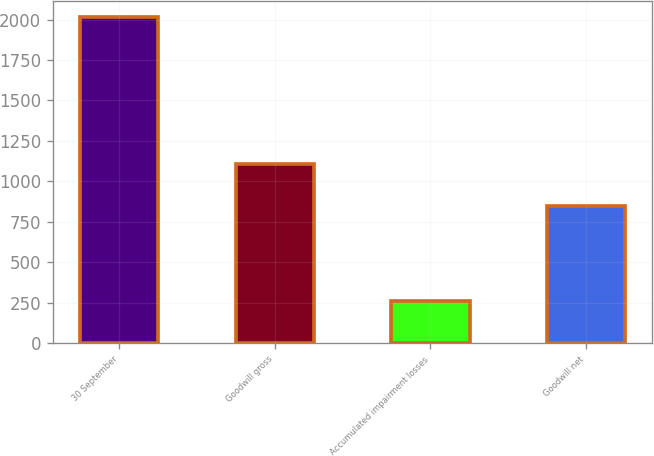Convert chart to OTSL. <chart><loc_0><loc_0><loc_500><loc_500><bar_chart><fcel>30 September<fcel>Goodwill gross<fcel>Accumulated impairment losses<fcel>Goodwill net<nl><fcel>2016<fcel>1103.7<fcel>258.6<fcel>845.1<nl></chart> 